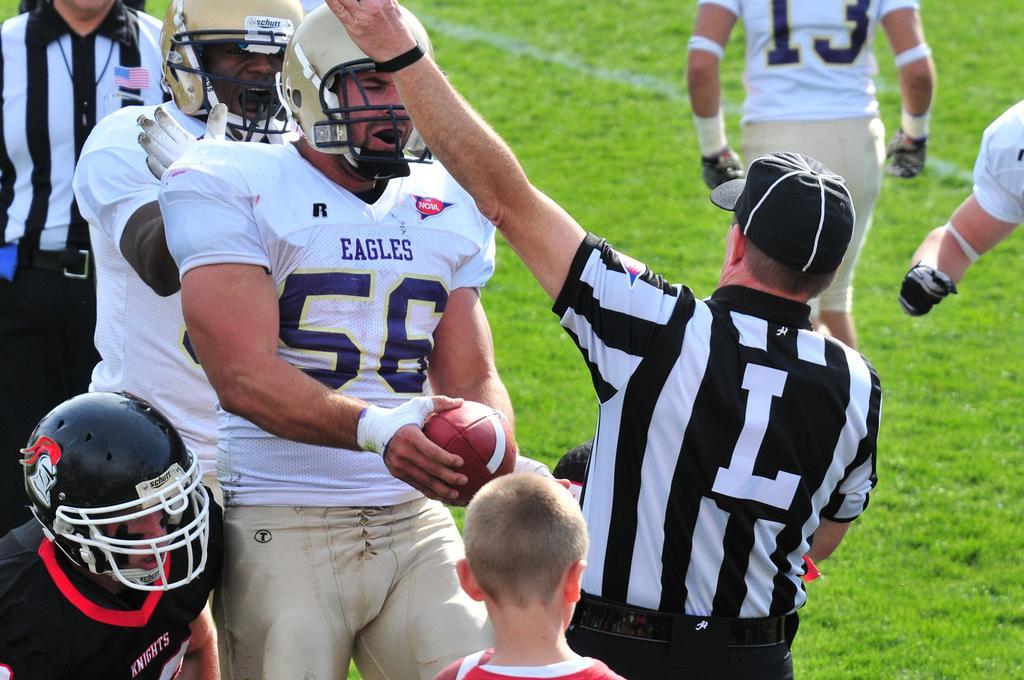Can you describe this image briefly? In this image we can see a group of persons. Behind the persons we can see the grass. We can see a person holding a ball in the foreground. 